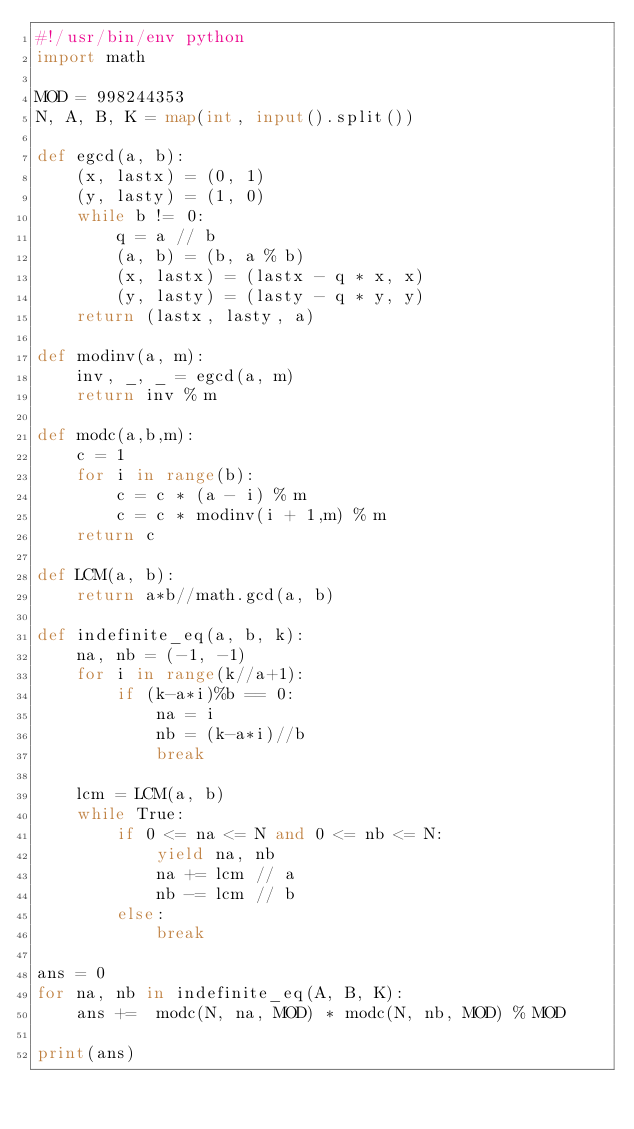Convert code to text. <code><loc_0><loc_0><loc_500><loc_500><_Python_>#!/usr/bin/env python
import math

MOD = 998244353
N, A, B, K = map(int, input().split())

def egcd(a, b):
    (x, lastx) = (0, 1)
    (y, lasty) = (1, 0)
    while b != 0:
        q = a // b
        (a, b) = (b, a % b)
        (x, lastx) = (lastx - q * x, x)
        (y, lasty) = (lasty - q * y, y)
    return (lastx, lasty, a)
 
def modinv(a, m):
    inv, _, _ = egcd(a, m)
    return inv % m

def modc(a,b,m):
    c = 1
    for i in range(b):
        c = c * (a - i) % m
        c = c * modinv(i + 1,m) % m
    return c

def LCM(a, b):
    return a*b//math.gcd(a, b)

def indefinite_eq(a, b, k):
    na, nb = (-1, -1)
    for i in range(k//a+1):
        if (k-a*i)%b == 0:
            na = i
            nb = (k-a*i)//b
            break
    
    lcm = LCM(a, b)
    while True:
        if 0 <= na <= N and 0 <= nb <= N:    
            yield na, nb
            na += lcm // a
            nb -= lcm // b
        else: 
            break

ans = 0
for na, nb in indefinite_eq(A, B, K):
    ans +=  modc(N, na, MOD) * modc(N, nb, MOD) % MOD

print(ans)</code> 